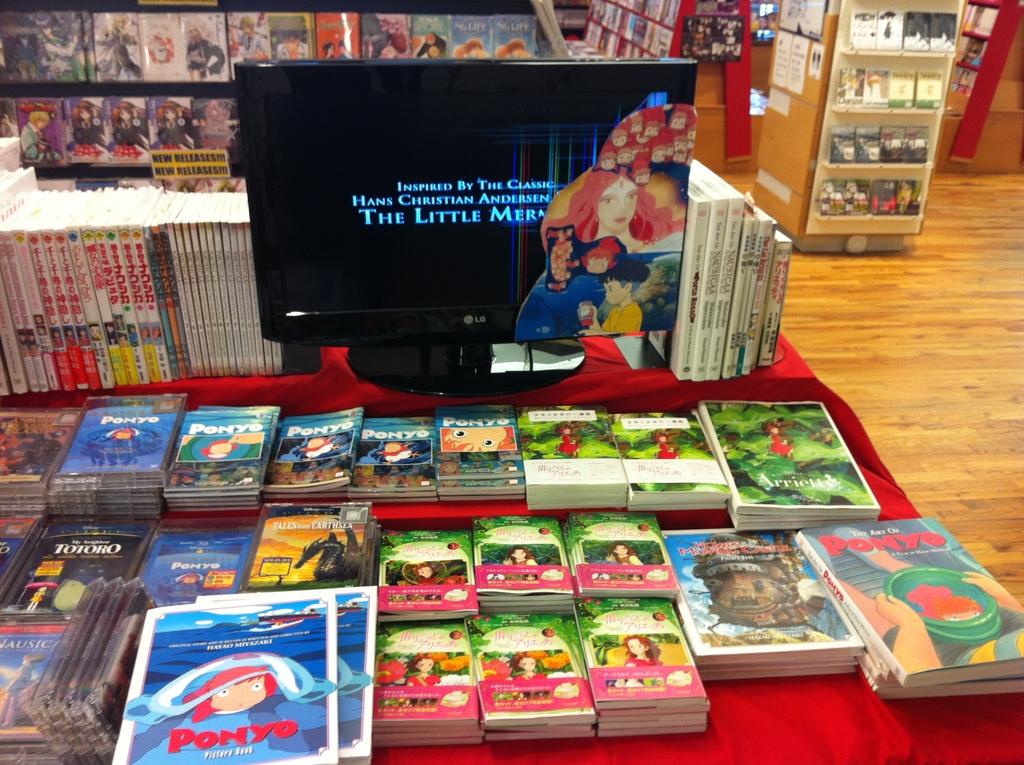What is the title of the movie displayed on the tv?
Ensure brevity in your answer.  The little mermaid. 